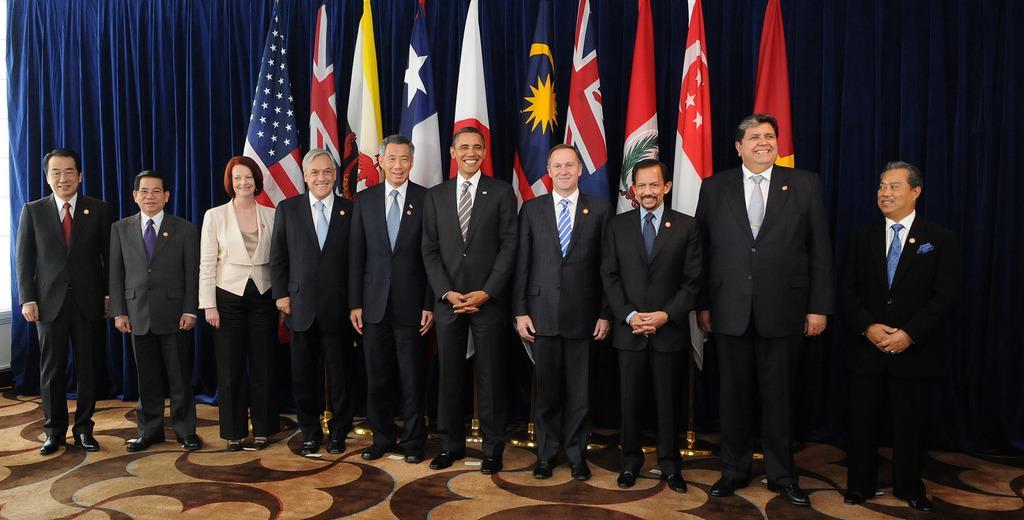In one or two sentences, can you explain what this image depicts? In this picture, we see many men and a woman are standing. All of them are smiling. Behind them, we see flags which are in blue, white, red and yellow color. Behind the flags, we see a curtain in blue color. This picture might be clicked in the conference hall. 